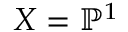<formula> <loc_0><loc_0><loc_500><loc_500>X = \mathbb { P } ^ { 1 }</formula> 